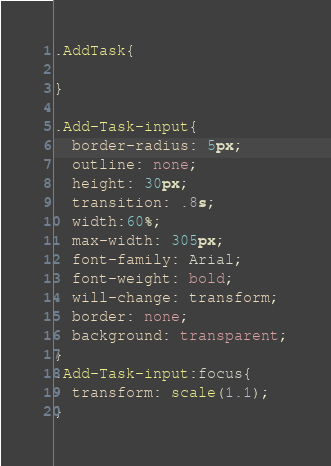<code> <loc_0><loc_0><loc_500><loc_500><_CSS_>.AddTask{
  
}

.Add-Task-input{
  border-radius: 5px;
  outline: none;
  height: 30px;
  transition: .8s;
  width:60%;
  max-width: 305px;
  font-family: Arial;
  font-weight: bold;
  will-change: transform;
  border: none;
  background: transparent;
}
.Add-Task-input:focus{
  transform: scale(1.1);
}</code> 